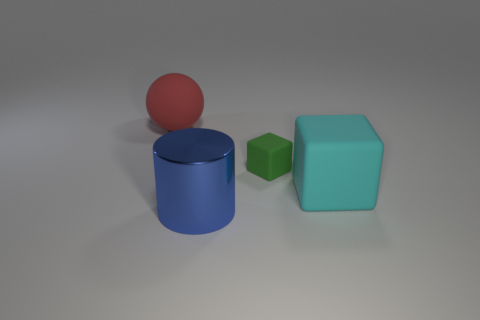Are there any other things that are the same material as the blue cylinder?
Keep it short and to the point. No. There is a object behind the green matte object; is it the same size as the small green thing?
Give a very brief answer. No. What number of small matte cubes are behind the large matte object in front of the thing that is behind the green thing?
Provide a succinct answer. 1. What number of brown things are matte objects or matte cylinders?
Offer a terse response. 0. What color is the ball that is made of the same material as the large cyan cube?
Provide a succinct answer. Red. Is there any other thing that is the same size as the green object?
Give a very brief answer. No. What number of large objects are either gray cylinders or cyan rubber objects?
Keep it short and to the point. 1. Is the number of blocks less than the number of tiny objects?
Provide a short and direct response. No. There is another thing that is the same shape as the tiny object; what color is it?
Your answer should be very brief. Cyan. Is there any other thing that has the same shape as the blue shiny object?
Provide a succinct answer. No. 